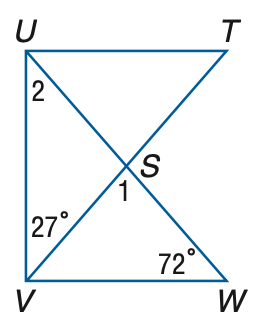Answer the mathemtical geometry problem and directly provide the correct option letter.
Question: If T U \perp U V and U V \perp V W, find m \angle 1.
Choices: A: 45 B: 47 C: 52 D: 55 A 